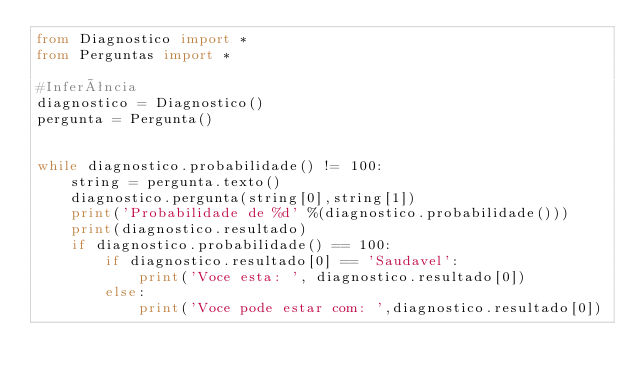Convert code to text. <code><loc_0><loc_0><loc_500><loc_500><_Python_>from Diagnostico import *
from Perguntas import *

#Inferência
diagnostico = Diagnostico()
pergunta = Pergunta()


while diagnostico.probabilidade() != 100:
	string = pergunta.texto()
	diagnostico.pergunta(string[0],string[1])
	print('Probabilidade de %d' %(diagnostico.probabilidade()))
	print(diagnostico.resultado)
	if diagnostico.probabilidade() == 100:
		if diagnostico.resultado[0] == 'Saudavel':
			print('Voce esta: ', diagnostico.resultado[0])
		else:
			print('Voce pode estar com: ',diagnostico.resultado[0])
</code> 